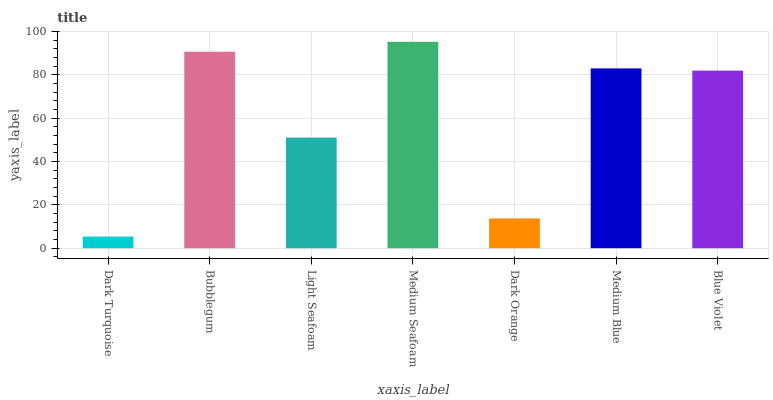Is Dark Turquoise the minimum?
Answer yes or no. Yes. Is Medium Seafoam the maximum?
Answer yes or no. Yes. Is Bubblegum the minimum?
Answer yes or no. No. Is Bubblegum the maximum?
Answer yes or no. No. Is Bubblegum greater than Dark Turquoise?
Answer yes or no. Yes. Is Dark Turquoise less than Bubblegum?
Answer yes or no. Yes. Is Dark Turquoise greater than Bubblegum?
Answer yes or no. No. Is Bubblegum less than Dark Turquoise?
Answer yes or no. No. Is Blue Violet the high median?
Answer yes or no. Yes. Is Blue Violet the low median?
Answer yes or no. Yes. Is Bubblegum the high median?
Answer yes or no. No. Is Dark Orange the low median?
Answer yes or no. No. 